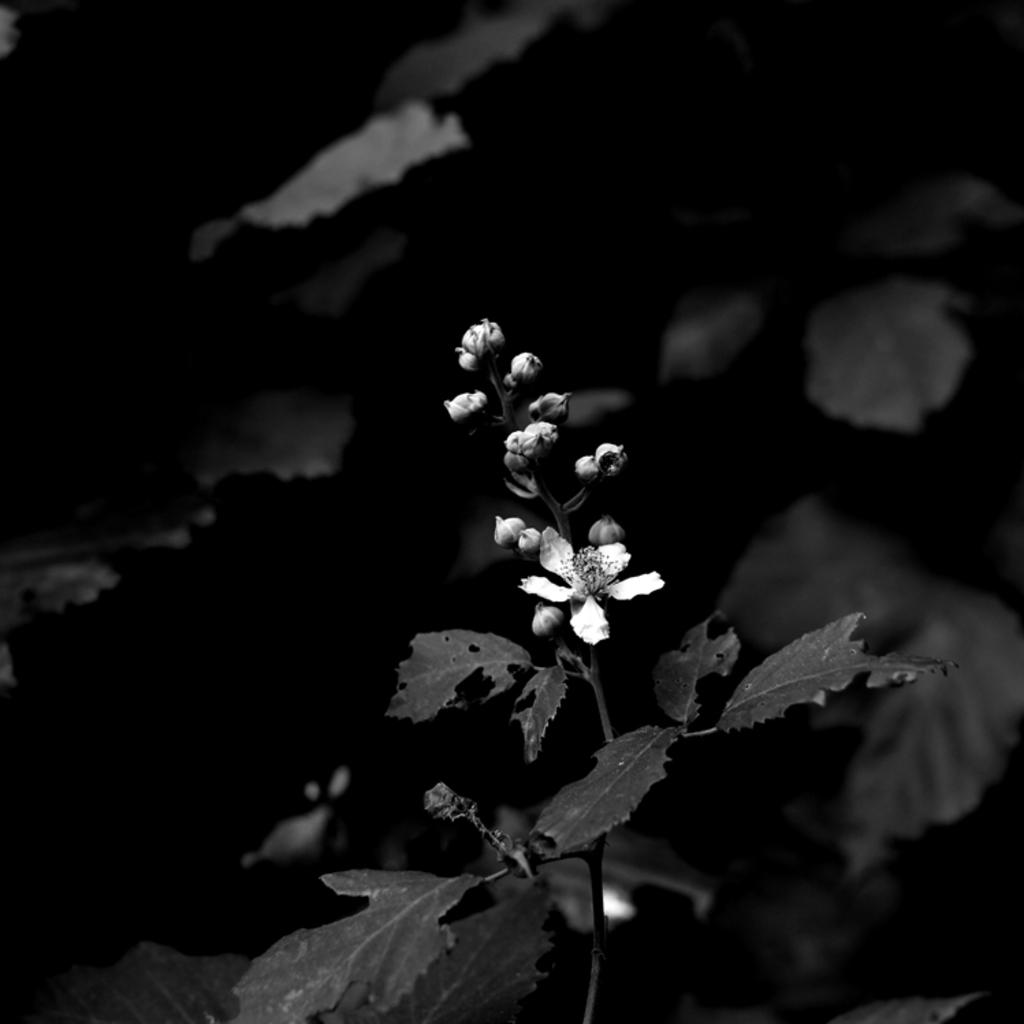What is the overall lighting condition in the image? The image is dark. What type of plant can be seen in the image? There is a flower in the image. What else is present in the image along with the flower? There are leaves in the image. How many goldfish are swimming in the image? There are no goldfish present in the image. What type of maid is featured in the image? There is no maid present in the image. 